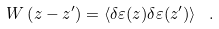Convert formula to latex. <formula><loc_0><loc_0><loc_500><loc_500>W \left ( z - z ^ { \prime } \right ) = \left \langle \delta \varepsilon ( z ) \delta \varepsilon ( z ^ { \prime } ) \right \rangle \ .</formula> 